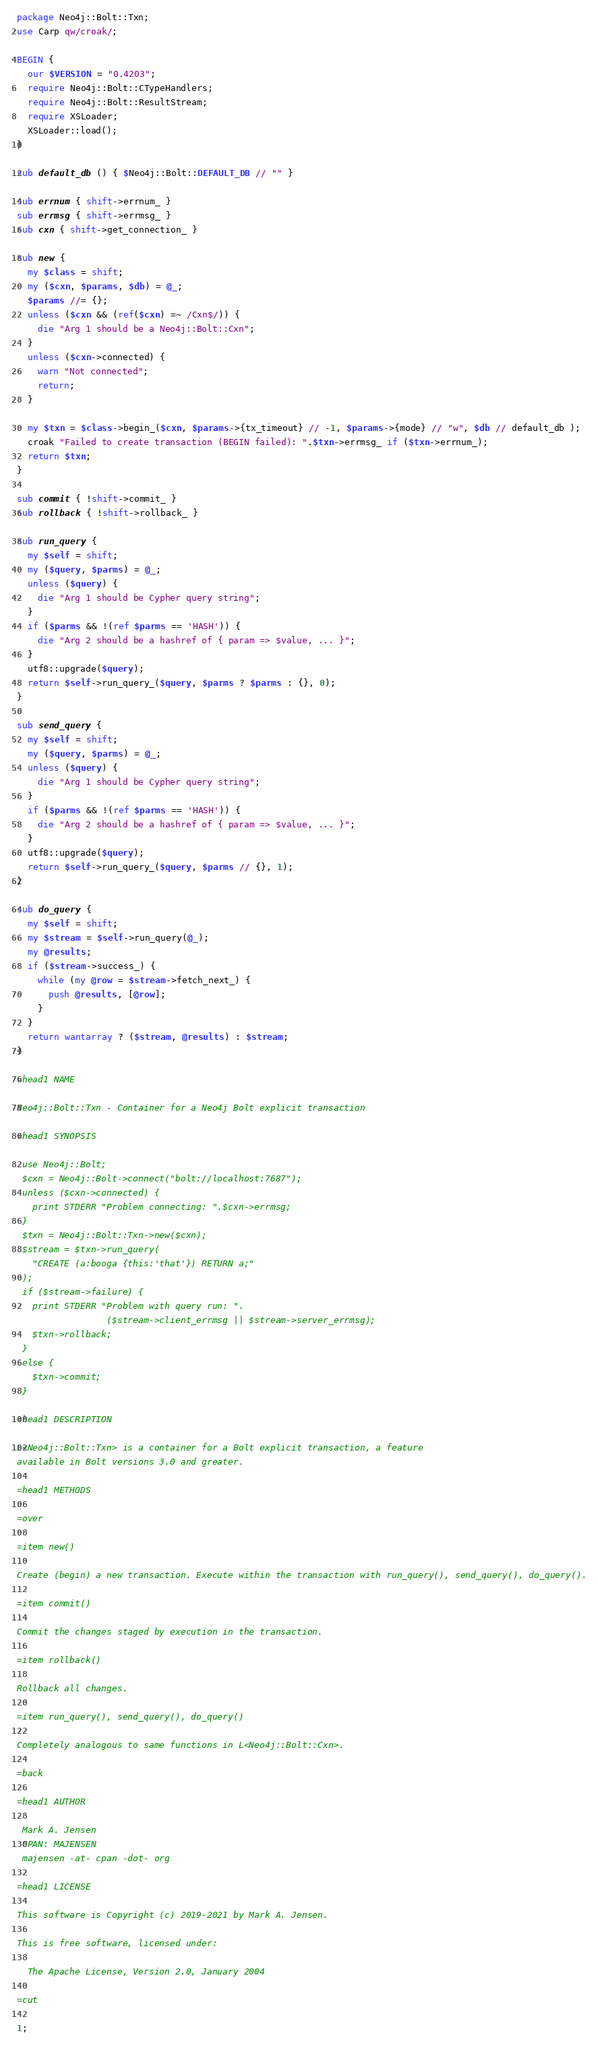<code> <loc_0><loc_0><loc_500><loc_500><_Perl_>package Neo4j::Bolt::Txn;
use Carp qw/croak/;

BEGIN {
  our $VERSION = "0.4203";
  require Neo4j::Bolt::CTypeHandlers;
  require Neo4j::Bolt::ResultStream;  
  require XSLoader;
  XSLoader::load();
}

sub default_db () { $Neo4j::Bolt::DEFAULT_DB // "" }

sub errnum { shift->errnum_ }
sub errmsg { shift->errmsg_ }
sub cxn { shift->get_connection_ }

sub new {
  my $class = shift;
  my ($cxn, $params, $db) = @_;
  $params //= {};
  unless ($cxn && (ref($cxn) =~ /Cxn$/)) {
    die "Arg 1 should be a Neo4j::Bolt::Cxn";
  }
  unless ($cxn->connected) {
    warn "Not connected";
    return;
  }

  my $txn = $class->begin_($cxn, $params->{tx_timeout} // -1, $params->{mode} // "w", $db // default_db );
  croak "Failed to create transaction (BEGIN failed): ".$txn->errmsg_ if ($txn->errnum_);
  return $txn;
}

sub commit { !shift->commit_ }
sub rollback { !shift->rollback_ }

sub run_query {
  my $self = shift;
  my ($query, $parms) = @_;
  unless ($query) {
    die "Arg 1 should be Cypher query string";
  }
  if ($parms && !(ref $parms == 'HASH')) {
    die "Arg 2 should be a hashref of { param => $value, ... }";
  }
  utf8::upgrade($query);
  return $self->run_query_($query, $parms ? $parms : {}, 0);
}

sub send_query {
  my $self = shift;
  my ($query, $parms) = @_;
  unless ($query) {
    die "Arg 1 should be Cypher query string";
  }
  if ($parms && !(ref $parms == 'HASH')) {
    die "Arg 2 should be a hashref of { param => $value, ... }";
  }
  utf8::upgrade($query);
  return $self->run_query_($query, $parms // {}, 1);
}

sub do_query {
  my $self = shift;
  my $stream = $self->run_query(@_);
  my @results;
  if ($stream->success_) {
    while (my @row = $stream->fetch_next_) {
      push @results, [@row];
    }
  }
  return wantarray ? ($stream, @results) : $stream;
}

=head1 NAME

Neo4j::Bolt::Txn - Container for a Neo4j Bolt explicit transaction

=head1 SYNOPSIS

 use Neo4j::Bolt;
 $cxn = Neo4j::Bolt->connect("bolt://localhost:7687");
 unless ($cxn->connected) {
   print STDERR "Problem connecting: ".$cxn->errmsg;
 }
 $txn = Neo4j::Bolt::Txn->new($cxn);
 $stream = $txn->run_query(
   "CREATE (a:booga {this:'that'}) RETURN a;"
 );
 if ($stream->failure) {
   print STDERR "Problem with query run: ".
                 ($stream->client_errmsg || $stream->server_errmsg);
   $txn->rollback;
 }
 else {
   $txn->commit;
 }

=head1 DESCRIPTION

L<Neo4j::Bolt::Txn> is a container for a Bolt explicit transaction, a feature
available in Bolt versions 3.0 and greater.

=head1 METHODS

=over

=item new()

Create (begin) a new transaction. Execute within the transaction with run_query(), send_query(), do_query().

=item commit()

Commit the changes staged by execution in the transaction.

=item rollback()

Rollback all changes.

=item run_query(), send_query(), do_query()

Completely analogous to same functions in L<Neo4j::Bolt::Cxn>.

=back

=head1 AUTHOR

 Mark A. Jensen
 CPAN: MAJENSEN
 majensen -at- cpan -dot- org

=head1 LICENSE

This software is Copyright (c) 2019-2021 by Mark A. Jensen.

This is free software, licensed under:

  The Apache License, Version 2.0, January 2004

=cut

1;
</code> 